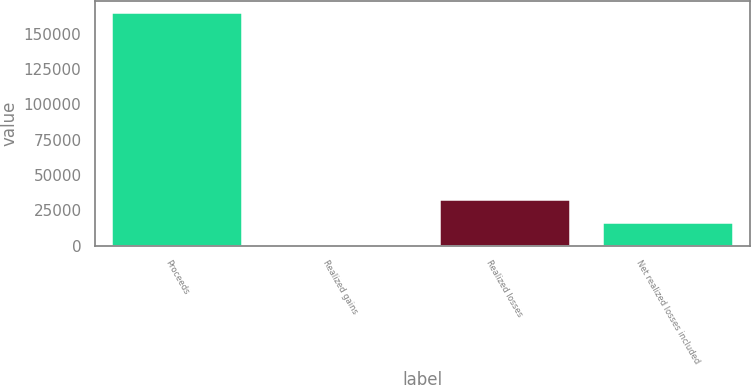Convert chart. <chart><loc_0><loc_0><loc_500><loc_500><bar_chart><fcel>Proceeds<fcel>Realized gains<fcel>Realized losses<fcel>Net realized losses included<nl><fcel>165177<fcel>376<fcel>33336.2<fcel>16856.1<nl></chart> 